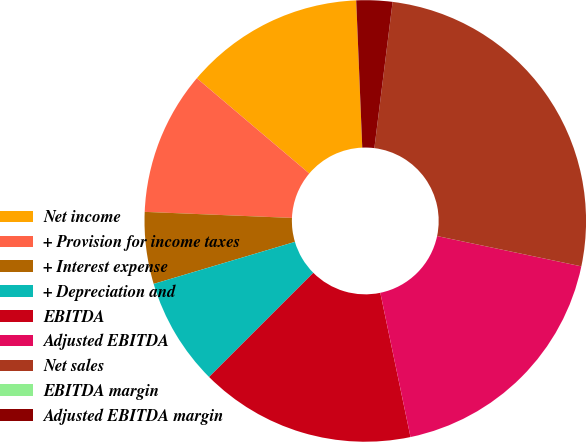<chart> <loc_0><loc_0><loc_500><loc_500><pie_chart><fcel>Net income<fcel>+ Provision for income taxes<fcel>+ Interest expense<fcel>+ Depreciation and<fcel>EBITDA<fcel>Adjusted EBITDA<fcel>Net sales<fcel>EBITDA margin<fcel>Adjusted EBITDA margin<nl><fcel>13.16%<fcel>10.53%<fcel>5.26%<fcel>7.89%<fcel>15.79%<fcel>18.42%<fcel>26.32%<fcel>0.0%<fcel>2.63%<nl></chart> 